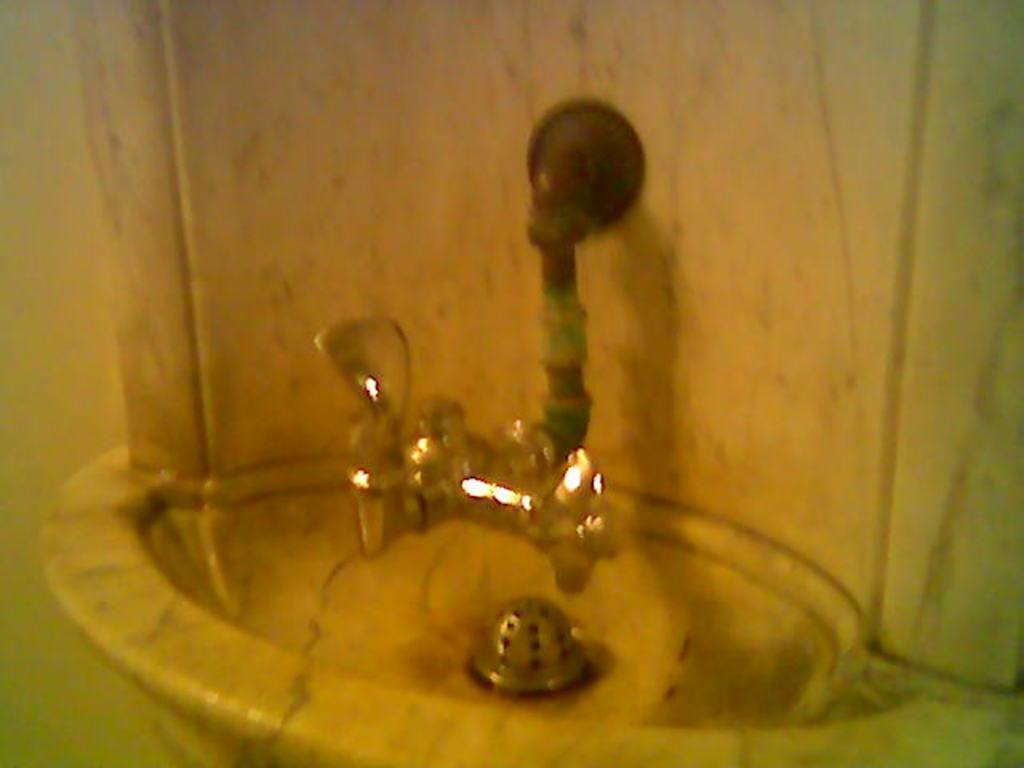Describe this image in one or two sentences. In the foreground of this image, it seems like a sink and there is a tap to the stone wall. 